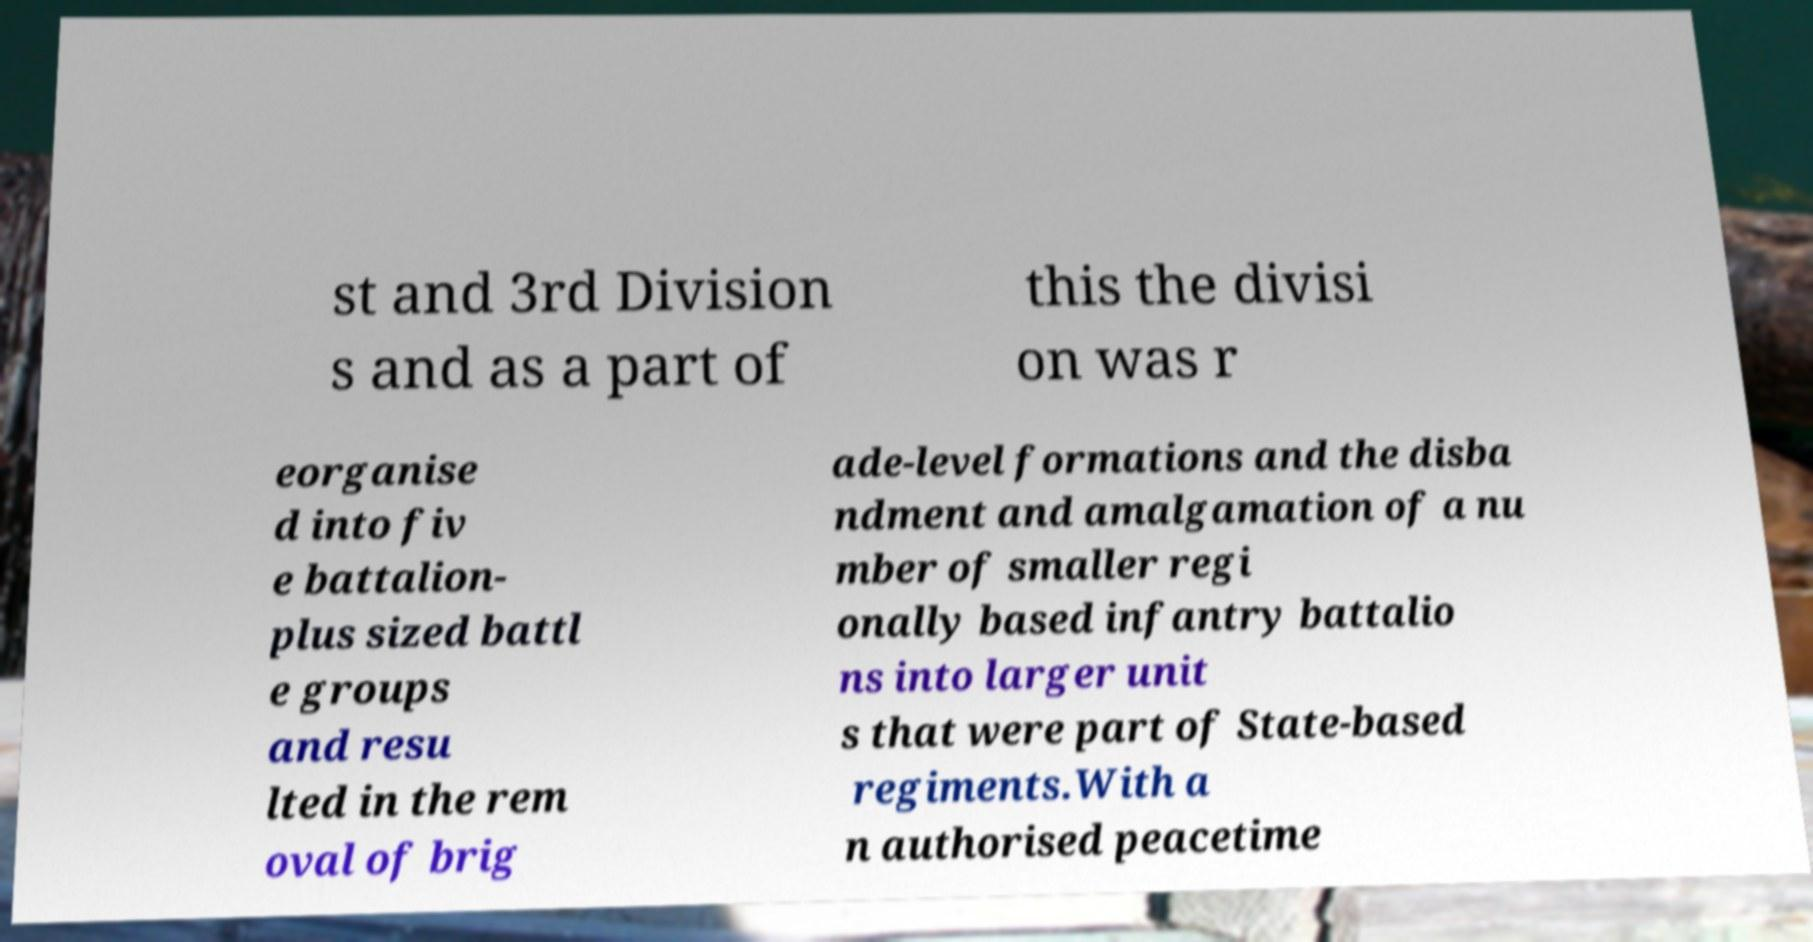Please read and relay the text visible in this image. What does it say? st and 3rd Division s and as a part of this the divisi on was r eorganise d into fiv e battalion- plus sized battl e groups and resu lted in the rem oval of brig ade-level formations and the disba ndment and amalgamation of a nu mber of smaller regi onally based infantry battalio ns into larger unit s that were part of State-based regiments.With a n authorised peacetime 